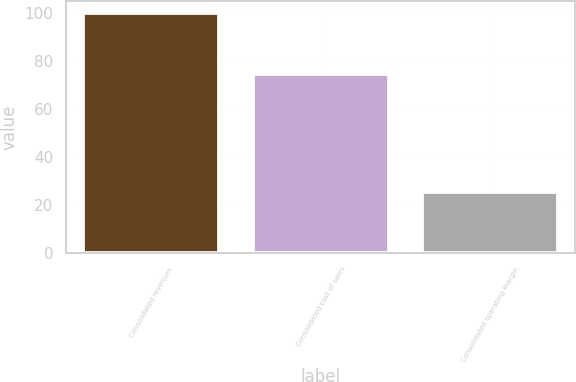Convert chart. <chart><loc_0><loc_0><loc_500><loc_500><bar_chart><fcel>Consolidated revenues<fcel>Consolidated cost of sales<fcel>Consolidated operating margin<nl><fcel>100<fcel>74.5<fcel>25.5<nl></chart> 